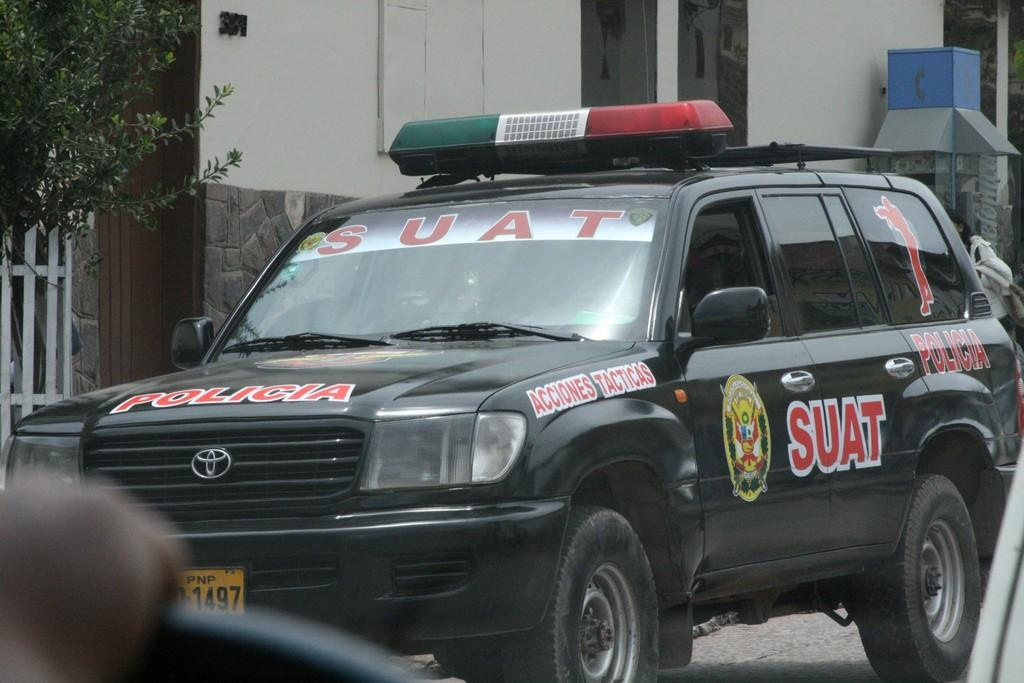What type of structure can be seen in the image? There is a building in the image. Can you describe the positioning of the buildings in the image? There is another building in front of the first building. What can be seen in the top left corner of the image? There is a plant in the top left corner of the image. What is located on the left side of the image? There is a fence on the left side of the image. How many rabbits are hopping around the fence in the image? There are no rabbits present in the image; only a building, another building, a plant, and a fence can be seen. 